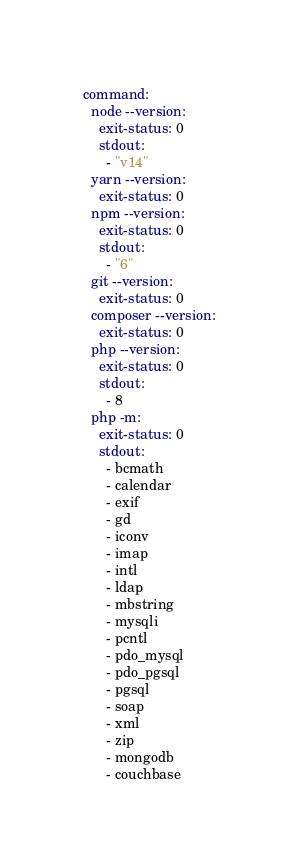<code> <loc_0><loc_0><loc_500><loc_500><_YAML_>command:
  node --version:
    exit-status: 0
    stdout:
      - "v14"
  yarn --version:
    exit-status: 0
  npm --version:
    exit-status: 0
    stdout:
      - "6"
  git --version:
    exit-status: 0
  composer --version:
    exit-status: 0
  php --version:
    exit-status: 0
    stdout:
      - 8
  php -m:
    exit-status: 0
    stdout:
      - bcmath
      - calendar
      - exif
      - gd
      - iconv
      - imap
      - intl
      - ldap
      - mbstring
      - mysqli
      - pcntl
      - pdo_mysql
      - pdo_pgsql
      - pgsql
      - soap
      - xml
      - zip
      - mongodb
      - couchbase
</code> 